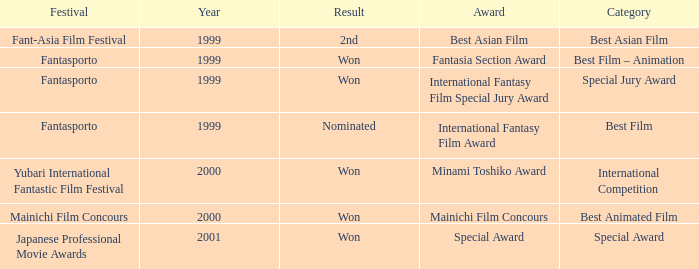What is the typical year of the fantasia section award? 1999.0. 